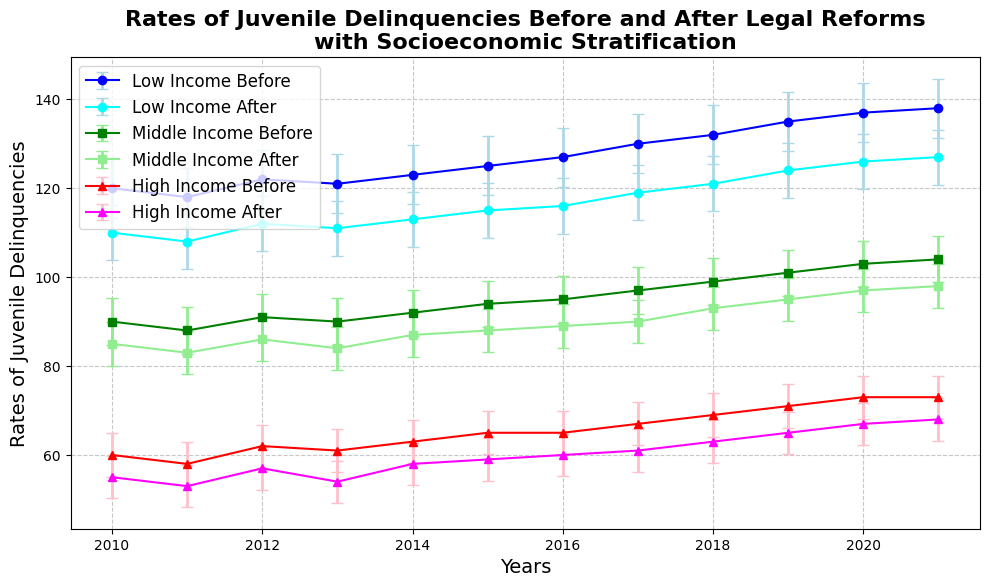Which year saw the highest rate of juvenile delinquencies for the high-income group before the reform? Identify the highest point on the "High Income Before" error bar plot. The marker for 2019 (71) is the highest.
Answer: 2019 Did juvenile delinquencies decrease after the reforms for the low-income group? Compare the trends of the "Low Income Before" and "Low Income After" lines. The "Low Income After" line is consistently lower than the "Low Income Before" line.
Answer: Yes Which income group shows the largest decline in delinquencies by 2021? Evaluate the difference in delinquencies before and after reforms for each income group in 2021. The difference is 11 (138-127) for low-income, 6 (104-98) for middle-income, and 5 (73-68) for high-income.
Answer: Low-income group What is the average number of delinquencies after the reforms for the middle-income group? Sum the middle-income after values (85, 83, 86, 84, 87, 88, 89, 90, 93, 95, 97, 98) and divide by 12. (85+83+86+84+87+88+89+90+93+95+97+98)=1075, then 1075/12=89.58
Answer: 89.58 Between 2020 and 2021, which income group had the smallest change in delinquency rates before the reforms? Compare the differences: low-income: (138-137)=1, middle-income: (104-103)=1, high-income: (73-73)=0. The high-income group has the smallest change (0).
Answer: High-income group How do the error bars for the high-income group before and after the reforms compare visually? Observe the width and overlap of the error bars for the high-income group's "Before" (red) and "After" (magenta) lines. Both have smaller error ranges, and often their error bars don’t overlap much, indicating more precise estimates.
Answer: Smaller and less overlap 